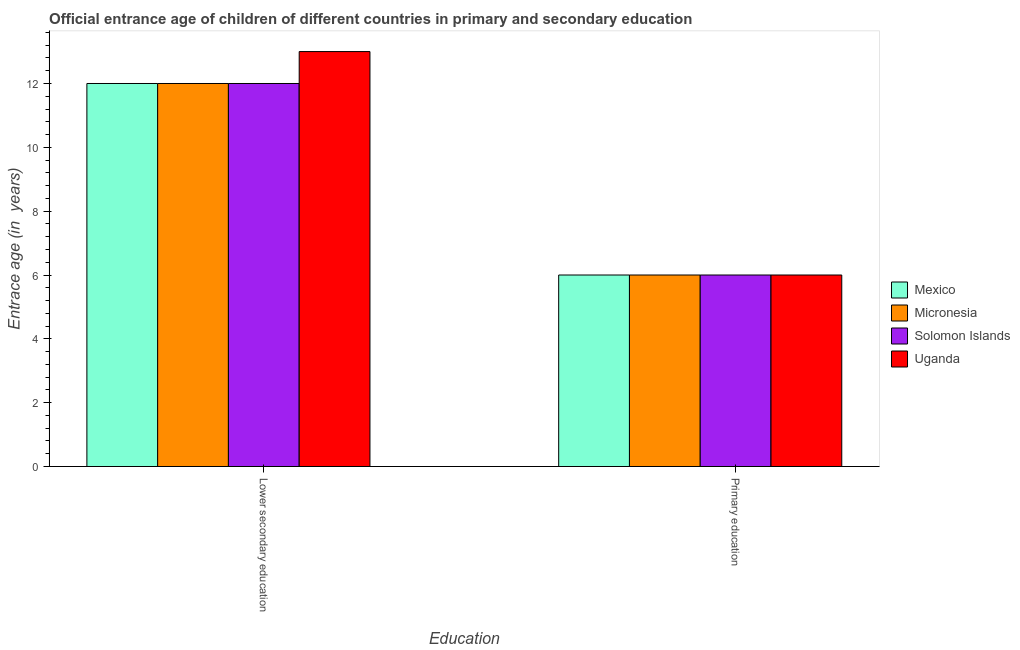How many groups of bars are there?
Provide a short and direct response. 2. Are the number of bars per tick equal to the number of legend labels?
Your response must be concise. Yes. How many bars are there on the 2nd tick from the left?
Offer a very short reply. 4. How many bars are there on the 2nd tick from the right?
Your response must be concise. 4. What is the label of the 2nd group of bars from the left?
Provide a short and direct response. Primary education. What is the entrance age of children in lower secondary education in Solomon Islands?
Make the answer very short. 12. Across all countries, what is the maximum entrance age of children in lower secondary education?
Give a very brief answer. 13. In which country was the entrance age of chiildren in primary education maximum?
Make the answer very short. Mexico. In which country was the entrance age of children in lower secondary education minimum?
Ensure brevity in your answer.  Mexico. What is the total entrance age of chiildren in primary education in the graph?
Your answer should be very brief. 24. What is the difference between the entrance age of children in lower secondary education in Mexico and the entrance age of chiildren in primary education in Micronesia?
Provide a short and direct response. 6. What is the average entrance age of children in lower secondary education per country?
Make the answer very short. 12.25. What is the difference between the entrance age of chiildren in primary education and entrance age of children in lower secondary education in Uganda?
Your answer should be very brief. -7. What is the ratio of the entrance age of children in lower secondary education in Uganda to that in Solomon Islands?
Your response must be concise. 1.08. In how many countries, is the entrance age of children in lower secondary education greater than the average entrance age of children in lower secondary education taken over all countries?
Provide a succinct answer. 1. What does the 2nd bar from the left in Primary education represents?
Your answer should be very brief. Micronesia. What does the 3rd bar from the right in Primary education represents?
Provide a succinct answer. Micronesia. How many countries are there in the graph?
Ensure brevity in your answer.  4. What is the difference between two consecutive major ticks on the Y-axis?
Offer a terse response. 2. Are the values on the major ticks of Y-axis written in scientific E-notation?
Give a very brief answer. No. How many legend labels are there?
Offer a very short reply. 4. What is the title of the graph?
Offer a very short reply. Official entrance age of children of different countries in primary and secondary education. What is the label or title of the X-axis?
Offer a very short reply. Education. What is the label or title of the Y-axis?
Offer a terse response. Entrace age (in  years). What is the Entrace age (in  years) in Micronesia in Lower secondary education?
Your answer should be compact. 12. What is the Entrace age (in  years) of Mexico in Primary education?
Ensure brevity in your answer.  6. What is the Entrace age (in  years) in Micronesia in Primary education?
Keep it short and to the point. 6. Across all Education, what is the maximum Entrace age (in  years) of Micronesia?
Keep it short and to the point. 12. Across all Education, what is the maximum Entrace age (in  years) of Solomon Islands?
Make the answer very short. 12. Across all Education, what is the minimum Entrace age (in  years) in Mexico?
Offer a terse response. 6. Across all Education, what is the minimum Entrace age (in  years) of Micronesia?
Offer a terse response. 6. Across all Education, what is the minimum Entrace age (in  years) of Solomon Islands?
Your answer should be very brief. 6. What is the total Entrace age (in  years) in Mexico in the graph?
Give a very brief answer. 18. What is the total Entrace age (in  years) of Micronesia in the graph?
Offer a very short reply. 18. What is the total Entrace age (in  years) of Solomon Islands in the graph?
Your response must be concise. 18. What is the total Entrace age (in  years) of Uganda in the graph?
Your answer should be very brief. 19. What is the difference between the Entrace age (in  years) in Mexico in Lower secondary education and that in Primary education?
Provide a short and direct response. 6. What is the difference between the Entrace age (in  years) in Micronesia in Lower secondary education and that in Primary education?
Provide a succinct answer. 6. What is the difference between the Entrace age (in  years) of Solomon Islands in Lower secondary education and that in Primary education?
Your response must be concise. 6. What is the difference between the Entrace age (in  years) of Uganda in Lower secondary education and that in Primary education?
Offer a very short reply. 7. What is the difference between the Entrace age (in  years) in Micronesia in Lower secondary education and the Entrace age (in  years) in Solomon Islands in Primary education?
Offer a terse response. 6. What is the average Entrace age (in  years) in Micronesia per Education?
Your response must be concise. 9. What is the average Entrace age (in  years) of Uganda per Education?
Offer a very short reply. 9.5. What is the difference between the Entrace age (in  years) in Mexico and Entrace age (in  years) in Uganda in Lower secondary education?
Your answer should be very brief. -1. What is the difference between the Entrace age (in  years) in Micronesia and Entrace age (in  years) in Uganda in Lower secondary education?
Provide a short and direct response. -1. What is the difference between the Entrace age (in  years) of Solomon Islands and Entrace age (in  years) of Uganda in Lower secondary education?
Your response must be concise. -1. What is the difference between the Entrace age (in  years) in Mexico and Entrace age (in  years) in Uganda in Primary education?
Offer a very short reply. 0. What is the difference between the Entrace age (in  years) of Micronesia and Entrace age (in  years) of Solomon Islands in Primary education?
Offer a terse response. 0. What is the difference between the Entrace age (in  years) in Micronesia and Entrace age (in  years) in Uganda in Primary education?
Offer a terse response. 0. What is the difference between the Entrace age (in  years) of Solomon Islands and Entrace age (in  years) of Uganda in Primary education?
Your answer should be compact. 0. What is the ratio of the Entrace age (in  years) of Mexico in Lower secondary education to that in Primary education?
Ensure brevity in your answer.  2. What is the ratio of the Entrace age (in  years) in Solomon Islands in Lower secondary education to that in Primary education?
Keep it short and to the point. 2. What is the ratio of the Entrace age (in  years) in Uganda in Lower secondary education to that in Primary education?
Your response must be concise. 2.17. What is the difference between the highest and the second highest Entrace age (in  years) of Micronesia?
Make the answer very short. 6. What is the difference between the highest and the second highest Entrace age (in  years) of Uganda?
Give a very brief answer. 7. What is the difference between the highest and the lowest Entrace age (in  years) of Mexico?
Provide a short and direct response. 6. What is the difference between the highest and the lowest Entrace age (in  years) in Solomon Islands?
Your response must be concise. 6. What is the difference between the highest and the lowest Entrace age (in  years) of Uganda?
Offer a very short reply. 7. 